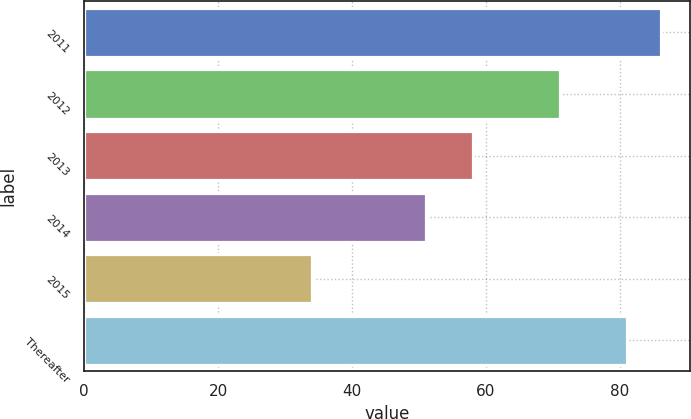<chart> <loc_0><loc_0><loc_500><loc_500><bar_chart><fcel>2011<fcel>2012<fcel>2013<fcel>2014<fcel>2015<fcel>Thereafter<nl><fcel>86.2<fcel>71<fcel>58<fcel>51<fcel>34<fcel>81<nl></chart> 